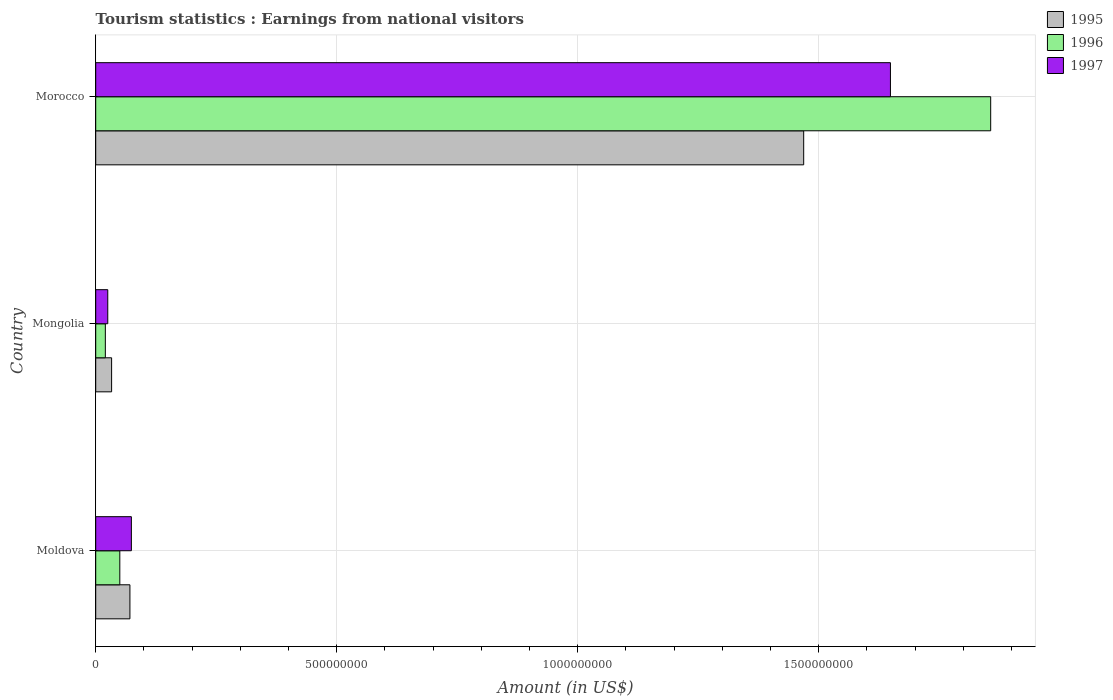How many different coloured bars are there?
Your response must be concise. 3. Are the number of bars on each tick of the Y-axis equal?
Make the answer very short. Yes. How many bars are there on the 2nd tick from the top?
Provide a succinct answer. 3. What is the label of the 1st group of bars from the top?
Your answer should be very brief. Morocco. In how many cases, is the number of bars for a given country not equal to the number of legend labels?
Your answer should be compact. 0. What is the earnings from national visitors in 1996 in Morocco?
Keep it short and to the point. 1.86e+09. Across all countries, what is the maximum earnings from national visitors in 1997?
Provide a short and direct response. 1.65e+09. Across all countries, what is the minimum earnings from national visitors in 1995?
Ensure brevity in your answer.  3.30e+07. In which country was the earnings from national visitors in 1995 maximum?
Offer a very short reply. Morocco. In which country was the earnings from national visitors in 1995 minimum?
Your answer should be very brief. Mongolia. What is the total earnings from national visitors in 1996 in the graph?
Offer a terse response. 1.93e+09. What is the difference between the earnings from national visitors in 1997 in Moldova and that in Morocco?
Your answer should be compact. -1.58e+09. What is the difference between the earnings from national visitors in 1997 in Moldova and the earnings from national visitors in 1996 in Mongolia?
Ensure brevity in your answer.  5.40e+07. What is the average earnings from national visitors in 1996 per country?
Provide a short and direct response. 6.42e+08. What is the difference between the earnings from national visitors in 1996 and earnings from national visitors in 1995 in Moldova?
Give a very brief answer. -2.10e+07. What is the ratio of the earnings from national visitors in 1995 in Moldova to that in Morocco?
Offer a very short reply. 0.05. Is the earnings from national visitors in 1995 in Mongolia less than that in Morocco?
Offer a terse response. Yes. What is the difference between the highest and the second highest earnings from national visitors in 1997?
Your answer should be very brief. 1.58e+09. What is the difference between the highest and the lowest earnings from national visitors in 1997?
Give a very brief answer. 1.62e+09. In how many countries, is the earnings from national visitors in 1996 greater than the average earnings from national visitors in 1996 taken over all countries?
Keep it short and to the point. 1. What does the 2nd bar from the bottom in Morocco represents?
Your response must be concise. 1996. How many bars are there?
Your response must be concise. 9. Are all the bars in the graph horizontal?
Offer a terse response. Yes. What is the difference between two consecutive major ticks on the X-axis?
Provide a succinct answer. 5.00e+08. Are the values on the major ticks of X-axis written in scientific E-notation?
Offer a very short reply. No. Does the graph contain grids?
Provide a short and direct response. Yes. How many legend labels are there?
Your answer should be very brief. 3. How are the legend labels stacked?
Provide a short and direct response. Vertical. What is the title of the graph?
Your answer should be very brief. Tourism statistics : Earnings from national visitors. Does "1997" appear as one of the legend labels in the graph?
Offer a very short reply. Yes. What is the label or title of the X-axis?
Your answer should be compact. Amount (in US$). What is the Amount (in US$) in 1995 in Moldova?
Give a very brief answer. 7.10e+07. What is the Amount (in US$) in 1996 in Moldova?
Offer a terse response. 5.00e+07. What is the Amount (in US$) of 1997 in Moldova?
Provide a short and direct response. 7.40e+07. What is the Amount (in US$) of 1995 in Mongolia?
Your answer should be very brief. 3.30e+07. What is the Amount (in US$) of 1997 in Mongolia?
Keep it short and to the point. 2.50e+07. What is the Amount (in US$) in 1995 in Morocco?
Offer a terse response. 1.47e+09. What is the Amount (in US$) of 1996 in Morocco?
Your answer should be very brief. 1.86e+09. What is the Amount (in US$) of 1997 in Morocco?
Your answer should be compact. 1.65e+09. Across all countries, what is the maximum Amount (in US$) of 1995?
Provide a succinct answer. 1.47e+09. Across all countries, what is the maximum Amount (in US$) in 1996?
Give a very brief answer. 1.86e+09. Across all countries, what is the maximum Amount (in US$) in 1997?
Keep it short and to the point. 1.65e+09. Across all countries, what is the minimum Amount (in US$) in 1995?
Make the answer very short. 3.30e+07. Across all countries, what is the minimum Amount (in US$) in 1996?
Give a very brief answer. 2.00e+07. Across all countries, what is the minimum Amount (in US$) of 1997?
Provide a succinct answer. 2.50e+07. What is the total Amount (in US$) in 1995 in the graph?
Keep it short and to the point. 1.57e+09. What is the total Amount (in US$) of 1996 in the graph?
Provide a succinct answer. 1.93e+09. What is the total Amount (in US$) in 1997 in the graph?
Provide a succinct answer. 1.75e+09. What is the difference between the Amount (in US$) in 1995 in Moldova and that in Mongolia?
Your answer should be very brief. 3.80e+07. What is the difference between the Amount (in US$) of 1996 in Moldova and that in Mongolia?
Your answer should be compact. 3.00e+07. What is the difference between the Amount (in US$) in 1997 in Moldova and that in Mongolia?
Provide a succinct answer. 4.90e+07. What is the difference between the Amount (in US$) of 1995 in Moldova and that in Morocco?
Provide a short and direct response. -1.40e+09. What is the difference between the Amount (in US$) of 1996 in Moldova and that in Morocco?
Offer a terse response. -1.81e+09. What is the difference between the Amount (in US$) in 1997 in Moldova and that in Morocco?
Give a very brief answer. -1.58e+09. What is the difference between the Amount (in US$) in 1995 in Mongolia and that in Morocco?
Your answer should be compact. -1.44e+09. What is the difference between the Amount (in US$) in 1996 in Mongolia and that in Morocco?
Ensure brevity in your answer.  -1.84e+09. What is the difference between the Amount (in US$) of 1997 in Mongolia and that in Morocco?
Provide a short and direct response. -1.62e+09. What is the difference between the Amount (in US$) in 1995 in Moldova and the Amount (in US$) in 1996 in Mongolia?
Offer a very short reply. 5.10e+07. What is the difference between the Amount (in US$) of 1995 in Moldova and the Amount (in US$) of 1997 in Mongolia?
Ensure brevity in your answer.  4.60e+07. What is the difference between the Amount (in US$) in 1996 in Moldova and the Amount (in US$) in 1997 in Mongolia?
Your answer should be compact. 2.50e+07. What is the difference between the Amount (in US$) of 1995 in Moldova and the Amount (in US$) of 1996 in Morocco?
Ensure brevity in your answer.  -1.79e+09. What is the difference between the Amount (in US$) of 1995 in Moldova and the Amount (in US$) of 1997 in Morocco?
Make the answer very short. -1.58e+09. What is the difference between the Amount (in US$) in 1996 in Moldova and the Amount (in US$) in 1997 in Morocco?
Provide a succinct answer. -1.60e+09. What is the difference between the Amount (in US$) in 1995 in Mongolia and the Amount (in US$) in 1996 in Morocco?
Your response must be concise. -1.82e+09. What is the difference between the Amount (in US$) of 1995 in Mongolia and the Amount (in US$) of 1997 in Morocco?
Offer a very short reply. -1.62e+09. What is the difference between the Amount (in US$) in 1996 in Mongolia and the Amount (in US$) in 1997 in Morocco?
Give a very brief answer. -1.63e+09. What is the average Amount (in US$) of 1995 per country?
Offer a terse response. 5.24e+08. What is the average Amount (in US$) in 1996 per country?
Offer a terse response. 6.42e+08. What is the average Amount (in US$) in 1997 per country?
Provide a short and direct response. 5.83e+08. What is the difference between the Amount (in US$) in 1995 and Amount (in US$) in 1996 in Moldova?
Provide a short and direct response. 2.10e+07. What is the difference between the Amount (in US$) of 1995 and Amount (in US$) of 1997 in Moldova?
Provide a short and direct response. -3.00e+06. What is the difference between the Amount (in US$) in 1996 and Amount (in US$) in 1997 in Moldova?
Offer a very short reply. -2.40e+07. What is the difference between the Amount (in US$) in 1995 and Amount (in US$) in 1996 in Mongolia?
Your answer should be compact. 1.30e+07. What is the difference between the Amount (in US$) of 1996 and Amount (in US$) of 1997 in Mongolia?
Ensure brevity in your answer.  -5.00e+06. What is the difference between the Amount (in US$) in 1995 and Amount (in US$) in 1996 in Morocco?
Offer a very short reply. -3.88e+08. What is the difference between the Amount (in US$) in 1995 and Amount (in US$) in 1997 in Morocco?
Your answer should be compact. -1.80e+08. What is the difference between the Amount (in US$) in 1996 and Amount (in US$) in 1997 in Morocco?
Keep it short and to the point. 2.08e+08. What is the ratio of the Amount (in US$) in 1995 in Moldova to that in Mongolia?
Your answer should be very brief. 2.15. What is the ratio of the Amount (in US$) of 1996 in Moldova to that in Mongolia?
Ensure brevity in your answer.  2.5. What is the ratio of the Amount (in US$) in 1997 in Moldova to that in Mongolia?
Your answer should be very brief. 2.96. What is the ratio of the Amount (in US$) of 1995 in Moldova to that in Morocco?
Your response must be concise. 0.05. What is the ratio of the Amount (in US$) in 1996 in Moldova to that in Morocco?
Offer a very short reply. 0.03. What is the ratio of the Amount (in US$) of 1997 in Moldova to that in Morocco?
Provide a short and direct response. 0.04. What is the ratio of the Amount (in US$) of 1995 in Mongolia to that in Morocco?
Offer a terse response. 0.02. What is the ratio of the Amount (in US$) of 1996 in Mongolia to that in Morocco?
Your answer should be compact. 0.01. What is the ratio of the Amount (in US$) in 1997 in Mongolia to that in Morocco?
Make the answer very short. 0.02. What is the difference between the highest and the second highest Amount (in US$) in 1995?
Your answer should be compact. 1.40e+09. What is the difference between the highest and the second highest Amount (in US$) of 1996?
Make the answer very short. 1.81e+09. What is the difference between the highest and the second highest Amount (in US$) of 1997?
Your answer should be compact. 1.58e+09. What is the difference between the highest and the lowest Amount (in US$) in 1995?
Offer a very short reply. 1.44e+09. What is the difference between the highest and the lowest Amount (in US$) of 1996?
Give a very brief answer. 1.84e+09. What is the difference between the highest and the lowest Amount (in US$) of 1997?
Provide a short and direct response. 1.62e+09. 